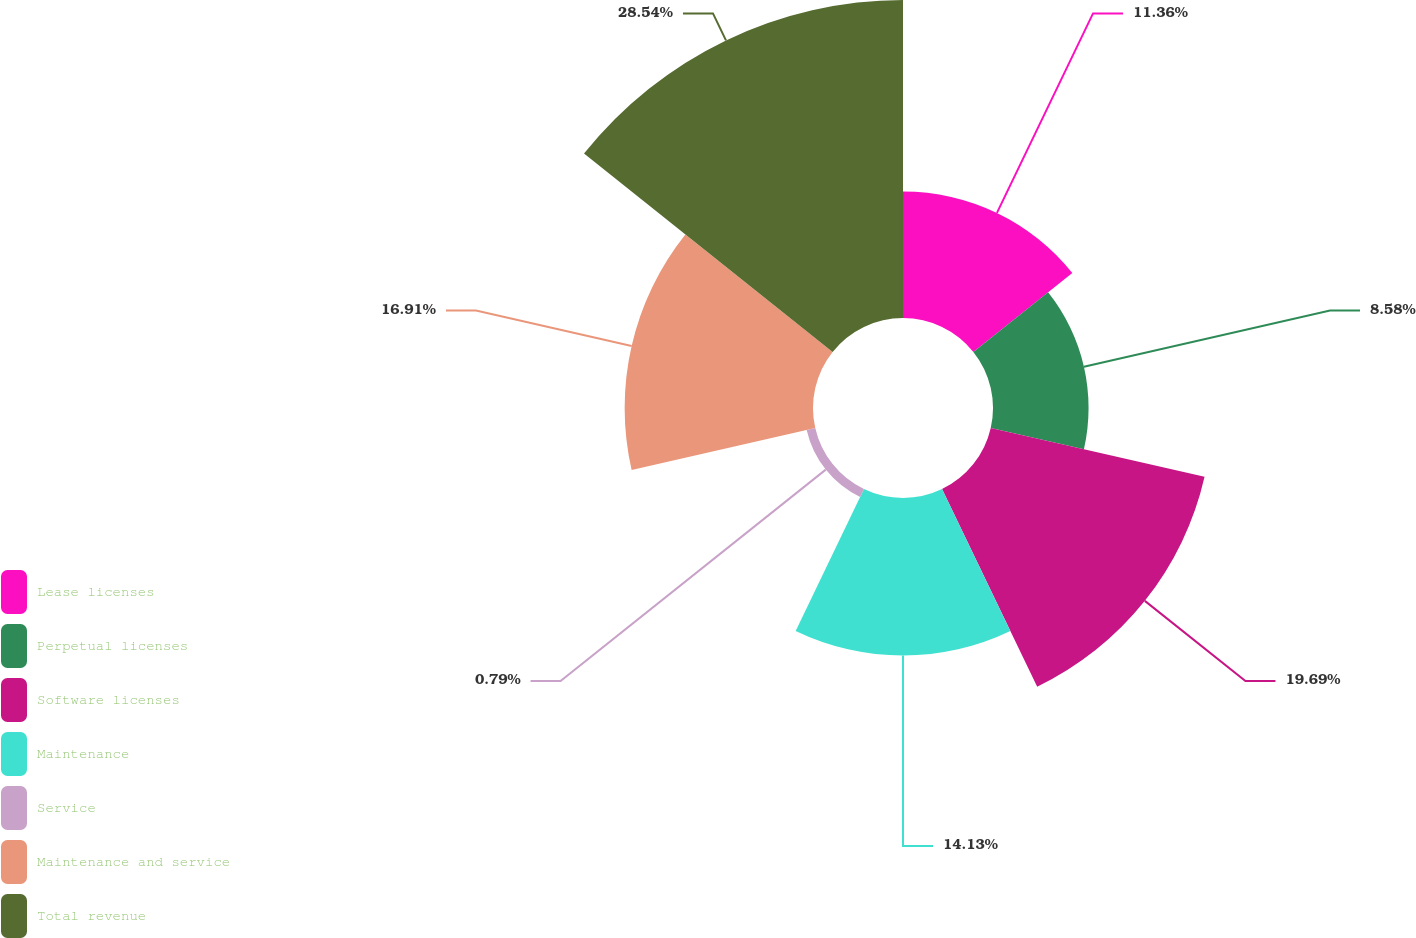Convert chart to OTSL. <chart><loc_0><loc_0><loc_500><loc_500><pie_chart><fcel>Lease licenses<fcel>Perpetual licenses<fcel>Software licenses<fcel>Maintenance<fcel>Service<fcel>Maintenance and service<fcel>Total revenue<nl><fcel>11.36%<fcel>8.58%<fcel>19.69%<fcel>14.13%<fcel>0.79%<fcel>16.91%<fcel>28.55%<nl></chart> 